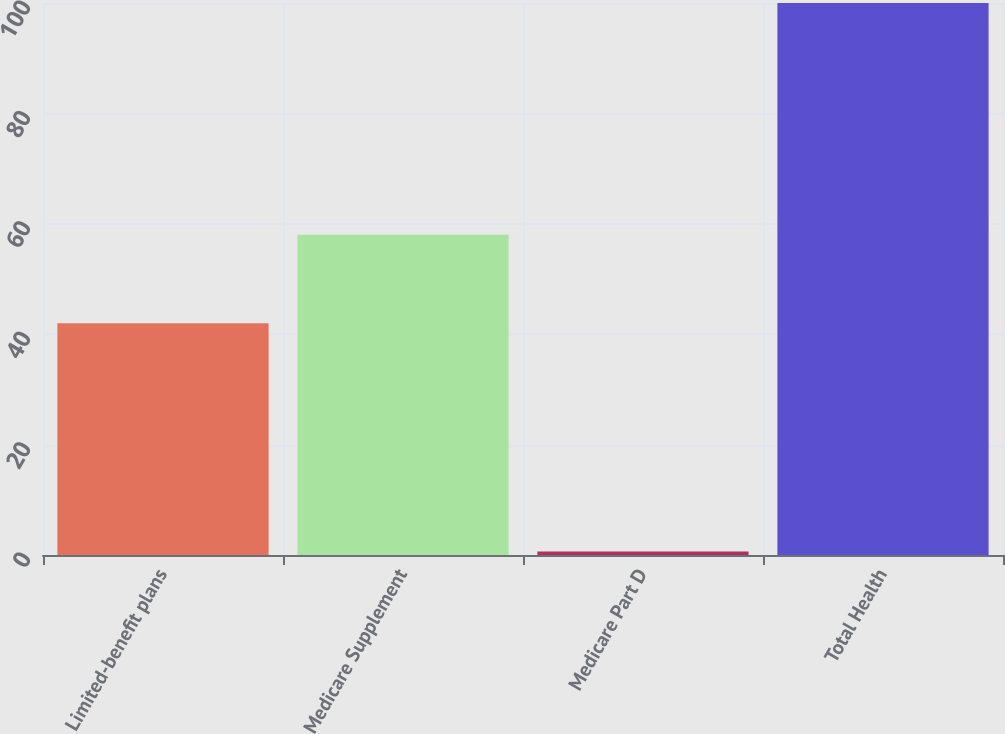Convert chart to OTSL. <chart><loc_0><loc_0><loc_500><loc_500><bar_chart><fcel>Limited-benefit plans<fcel>Medicare Supplement<fcel>Medicare Part D<fcel>Total Health<nl><fcel>42<fcel>58<fcel>0.62<fcel>100<nl></chart> 